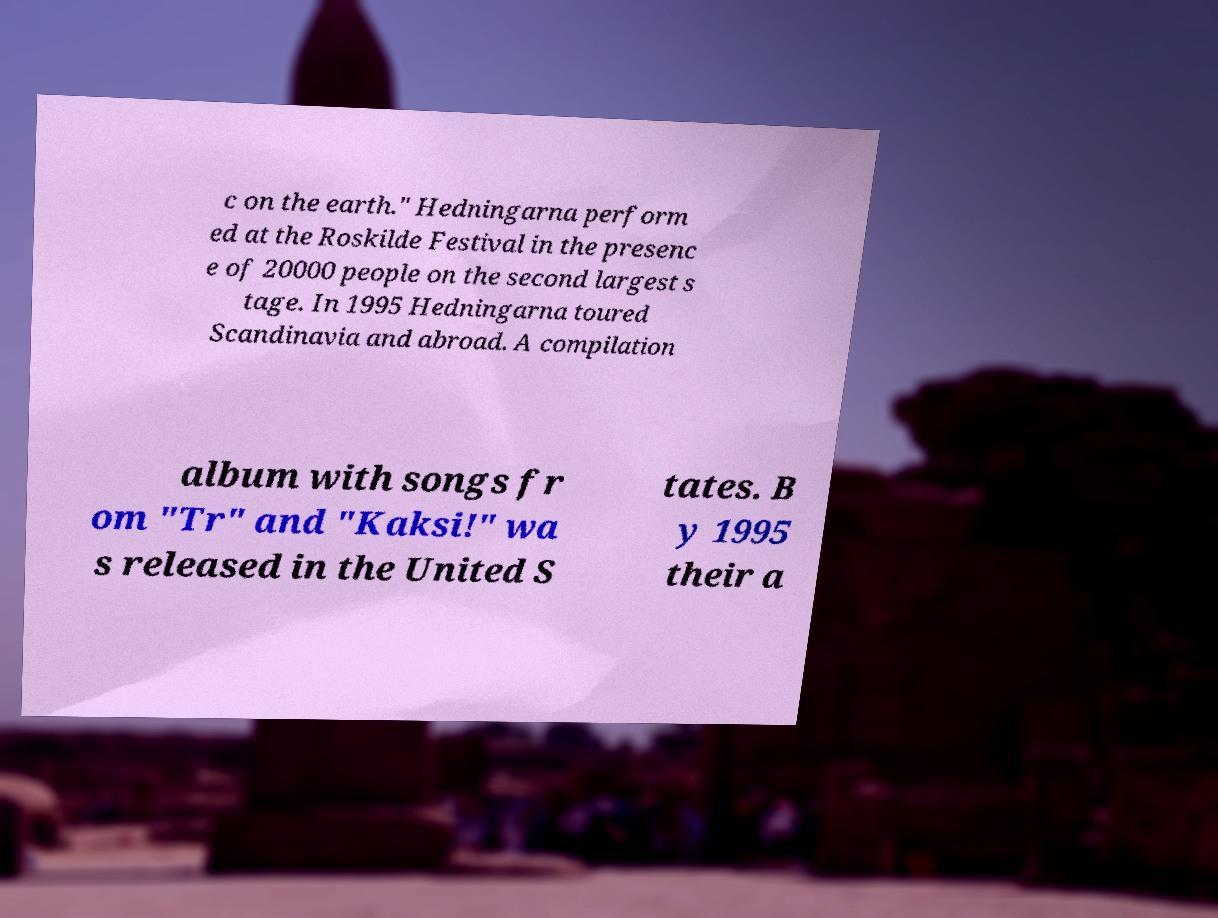Can you accurately transcribe the text from the provided image for me? c on the earth." Hedningarna perform ed at the Roskilde Festival in the presenc e of 20000 people on the second largest s tage. In 1995 Hedningarna toured Scandinavia and abroad. A compilation album with songs fr om "Tr" and "Kaksi!" wa s released in the United S tates. B y 1995 their a 